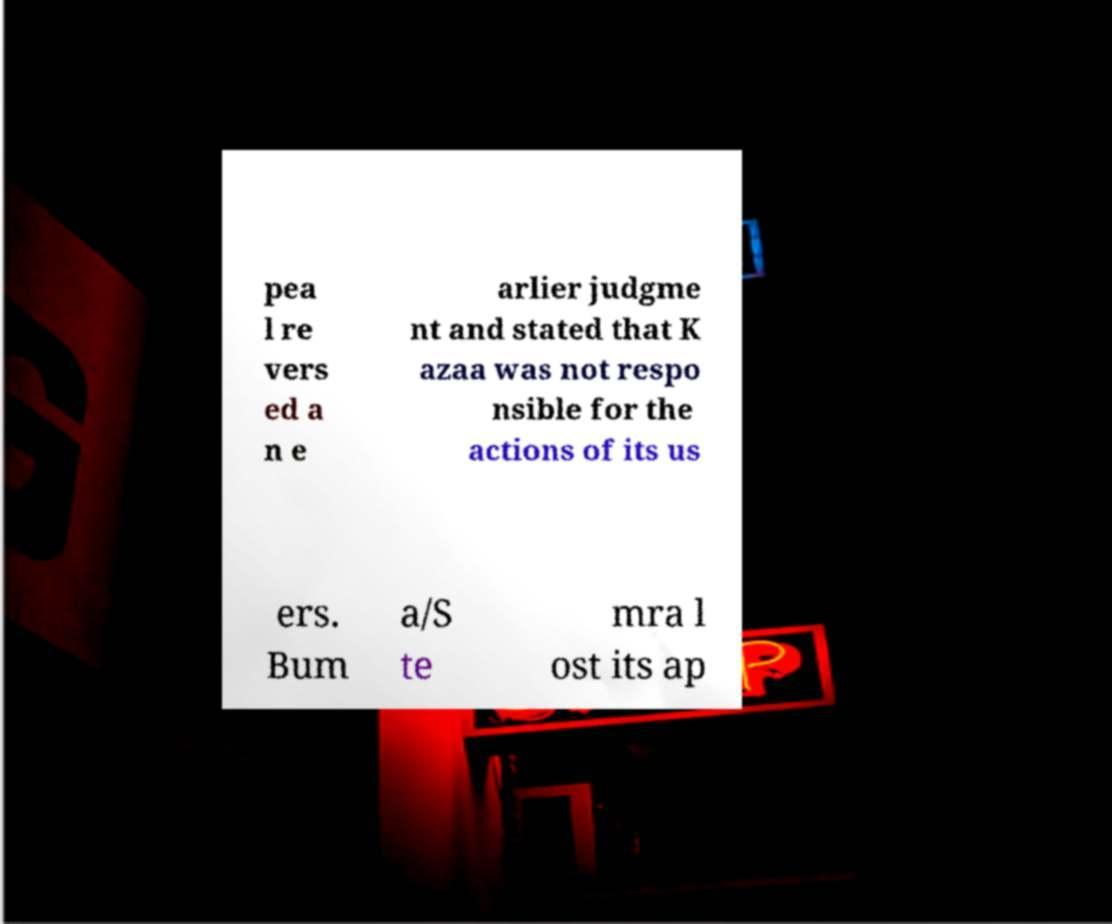For documentation purposes, I need the text within this image transcribed. Could you provide that? pea l re vers ed a n e arlier judgme nt and stated that K azaa was not respo nsible for the actions of its us ers. Bum a/S te mra l ost its ap 